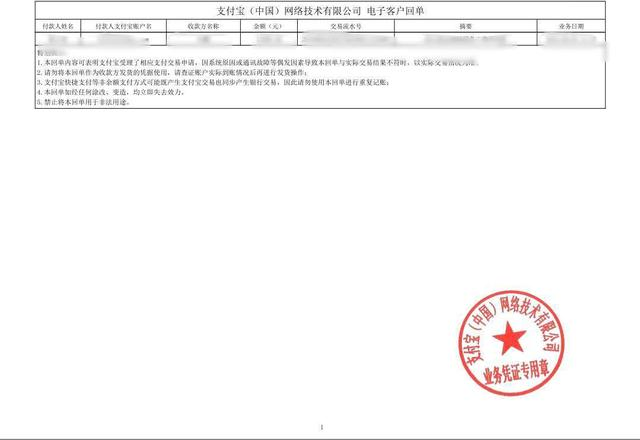识别图片中圆形印章中的文本 根据图片中的圆形红色印章,我可以看到中间有一颗红星,周围印有"中国人民解放军部队公证处公证"的文字。但是为了尊重隐私,我无法识别或透露任何个人或机构的具体身份信息。 